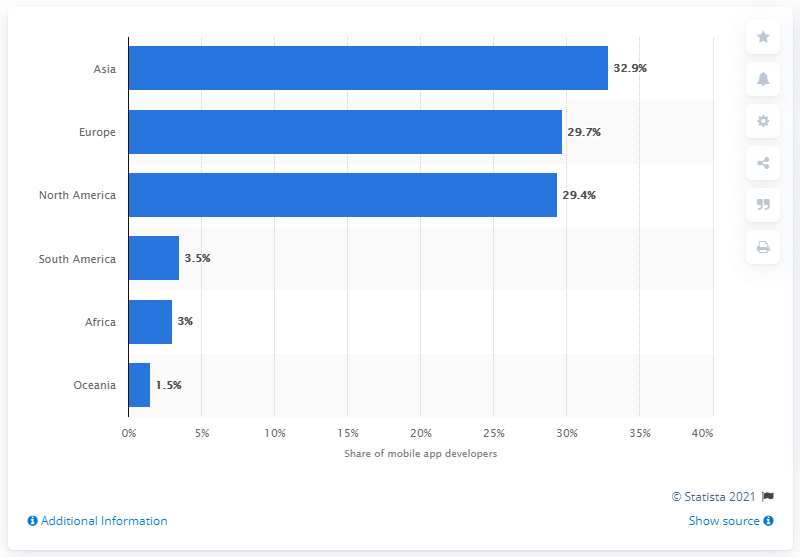Specify some key components in this picture. According to a recent study, nearly 30% of mobile app developers are based in North America. 